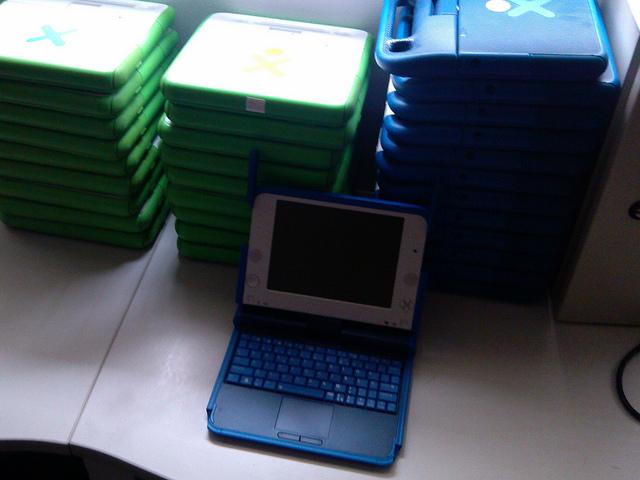Is the laptop on?
Answer briefly. No. What color is the desktop?
Quick response, please. White. What is the laptop sitting on?
Answer briefly. Desk. 